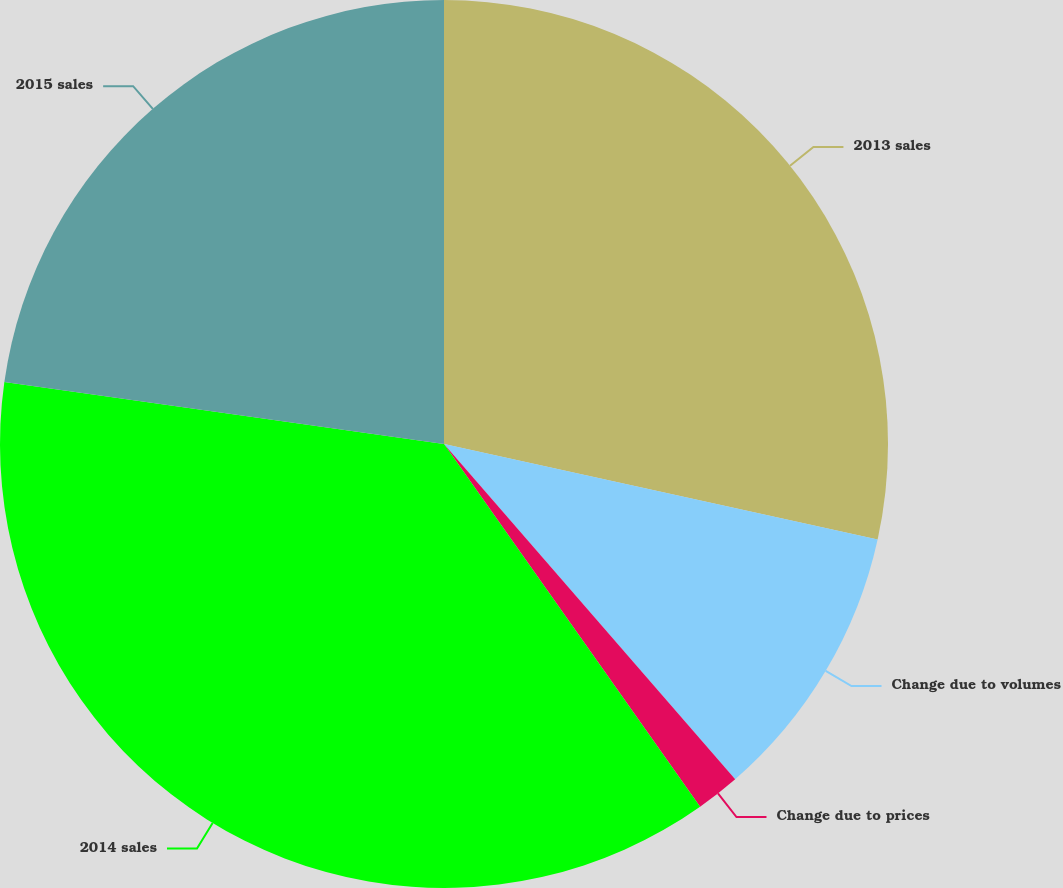Convert chart to OTSL. <chart><loc_0><loc_0><loc_500><loc_500><pie_chart><fcel>2013 sales<fcel>Change due to volumes<fcel>Change due to prices<fcel>2014 sales<fcel>2015 sales<nl><fcel>28.45%<fcel>10.17%<fcel>1.6%<fcel>37.02%<fcel>22.77%<nl></chart> 